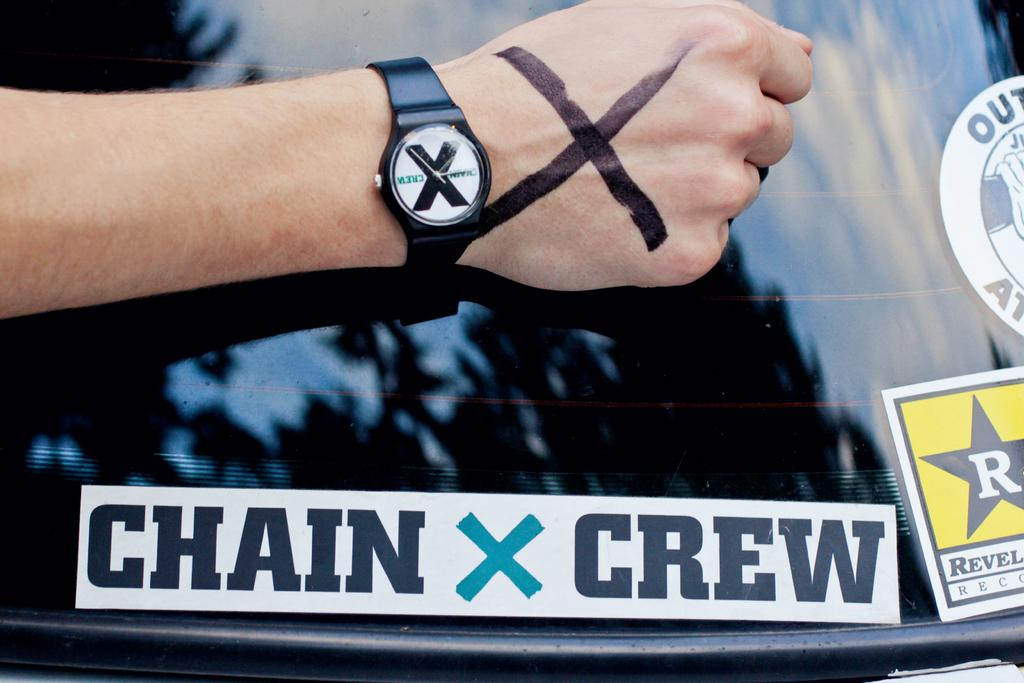<image>
Offer a succinct explanation of the picture presented. A person holds their hand out near a bumper sticker that says "chain X crew". 